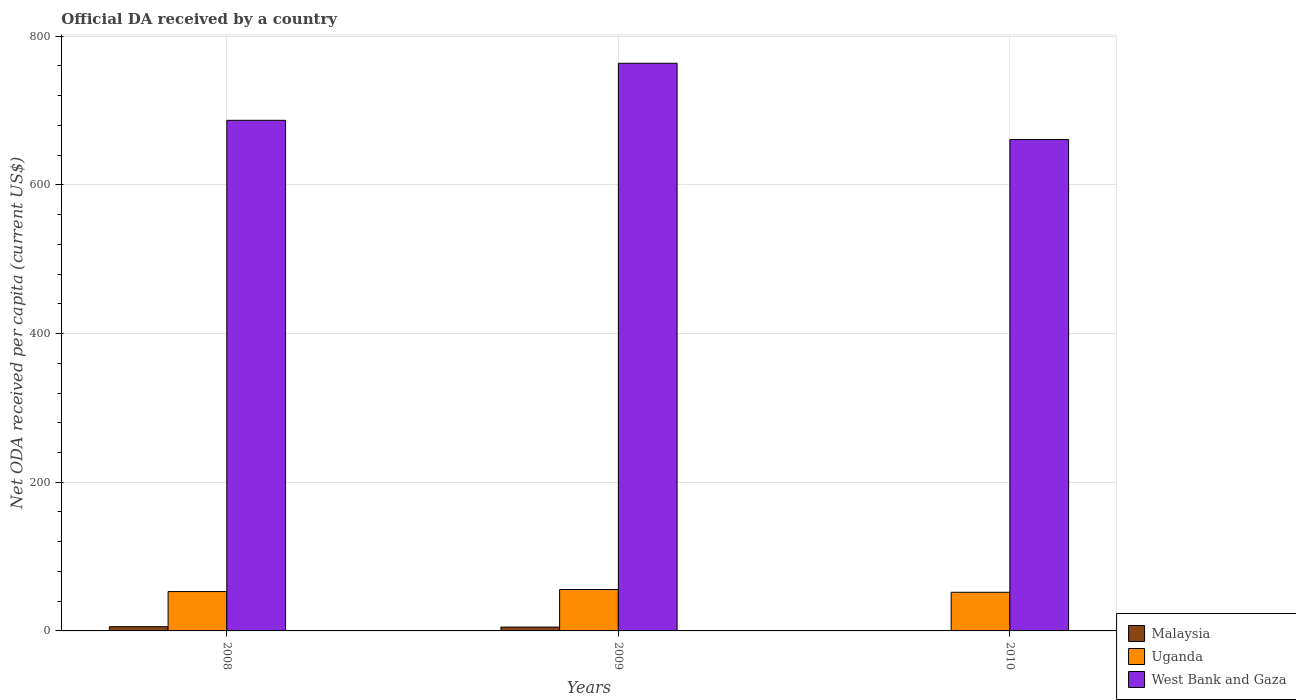Are the number of bars on each tick of the X-axis equal?
Make the answer very short. Yes. What is the label of the 2nd group of bars from the left?
Your answer should be very brief. 2009. What is the ODA received in in Uganda in 2008?
Your answer should be compact. 52.93. Across all years, what is the maximum ODA received in in West Bank and Gaza?
Provide a succinct answer. 763.51. Across all years, what is the minimum ODA received in in Malaysia?
Make the answer very short. 0.07. In which year was the ODA received in in Uganda maximum?
Your answer should be very brief. 2009. In which year was the ODA received in in Malaysia minimum?
Provide a succinct answer. 2010. What is the total ODA received in in Malaysia in the graph?
Your answer should be very brief. 10.92. What is the difference between the ODA received in in West Bank and Gaza in 2008 and that in 2009?
Provide a short and direct response. -76.74. What is the difference between the ODA received in in Malaysia in 2008 and the ODA received in in Uganda in 2010?
Keep it short and to the point. -46.31. What is the average ODA received in in Malaysia per year?
Ensure brevity in your answer.  3.64. In the year 2008, what is the difference between the ODA received in in Uganda and ODA received in in Malaysia?
Ensure brevity in your answer.  47.24. In how many years, is the ODA received in in Malaysia greater than 560 US$?
Keep it short and to the point. 0. What is the ratio of the ODA received in in West Bank and Gaza in 2008 to that in 2009?
Give a very brief answer. 0.9. Is the difference between the ODA received in in Uganda in 2009 and 2010 greater than the difference between the ODA received in in Malaysia in 2009 and 2010?
Provide a succinct answer. No. What is the difference between the highest and the second highest ODA received in in Uganda?
Your answer should be compact. 2.73. What is the difference between the highest and the lowest ODA received in in West Bank and Gaza?
Offer a terse response. 102.62. Is the sum of the ODA received in in Malaysia in 2008 and 2009 greater than the maximum ODA received in in Uganda across all years?
Your answer should be compact. No. What does the 1st bar from the left in 2009 represents?
Provide a succinct answer. Malaysia. What does the 2nd bar from the right in 2008 represents?
Your answer should be very brief. Uganda. Are all the bars in the graph horizontal?
Your response must be concise. No. How many years are there in the graph?
Make the answer very short. 3. What is the difference between two consecutive major ticks on the Y-axis?
Your response must be concise. 200. Are the values on the major ticks of Y-axis written in scientific E-notation?
Provide a succinct answer. No. Does the graph contain any zero values?
Make the answer very short. No. What is the title of the graph?
Give a very brief answer. Official DA received by a country. What is the label or title of the X-axis?
Keep it short and to the point. Years. What is the label or title of the Y-axis?
Offer a very short reply. Net ODA received per capita (current US$). What is the Net ODA received per capita (current US$) in Malaysia in 2008?
Ensure brevity in your answer.  5.68. What is the Net ODA received per capita (current US$) of Uganda in 2008?
Offer a terse response. 52.93. What is the Net ODA received per capita (current US$) in West Bank and Gaza in 2008?
Make the answer very short. 686.77. What is the Net ODA received per capita (current US$) of Malaysia in 2009?
Keep it short and to the point. 5.17. What is the Net ODA received per capita (current US$) in Uganda in 2009?
Provide a succinct answer. 55.66. What is the Net ODA received per capita (current US$) in West Bank and Gaza in 2009?
Your answer should be compact. 763.51. What is the Net ODA received per capita (current US$) in Malaysia in 2010?
Offer a terse response. 0.07. What is the Net ODA received per capita (current US$) of Uganda in 2010?
Ensure brevity in your answer.  51.99. What is the Net ODA received per capita (current US$) in West Bank and Gaza in 2010?
Make the answer very short. 660.88. Across all years, what is the maximum Net ODA received per capita (current US$) of Malaysia?
Your answer should be compact. 5.68. Across all years, what is the maximum Net ODA received per capita (current US$) in Uganda?
Your response must be concise. 55.66. Across all years, what is the maximum Net ODA received per capita (current US$) in West Bank and Gaza?
Provide a succinct answer. 763.51. Across all years, what is the minimum Net ODA received per capita (current US$) of Malaysia?
Your answer should be compact. 0.07. Across all years, what is the minimum Net ODA received per capita (current US$) in Uganda?
Your answer should be compact. 51.99. Across all years, what is the minimum Net ODA received per capita (current US$) in West Bank and Gaza?
Provide a short and direct response. 660.88. What is the total Net ODA received per capita (current US$) of Malaysia in the graph?
Provide a short and direct response. 10.92. What is the total Net ODA received per capita (current US$) in Uganda in the graph?
Your response must be concise. 160.57. What is the total Net ODA received per capita (current US$) in West Bank and Gaza in the graph?
Your response must be concise. 2111.16. What is the difference between the Net ODA received per capita (current US$) in Malaysia in 2008 and that in 2009?
Offer a terse response. 0.51. What is the difference between the Net ODA received per capita (current US$) of Uganda in 2008 and that in 2009?
Give a very brief answer. -2.73. What is the difference between the Net ODA received per capita (current US$) in West Bank and Gaza in 2008 and that in 2009?
Offer a very short reply. -76.74. What is the difference between the Net ODA received per capita (current US$) in Malaysia in 2008 and that in 2010?
Give a very brief answer. 5.61. What is the difference between the Net ODA received per capita (current US$) of Uganda in 2008 and that in 2010?
Offer a terse response. 0.94. What is the difference between the Net ODA received per capita (current US$) in West Bank and Gaza in 2008 and that in 2010?
Provide a succinct answer. 25.88. What is the difference between the Net ODA received per capita (current US$) in Malaysia in 2009 and that in 2010?
Offer a terse response. 5.09. What is the difference between the Net ODA received per capita (current US$) in Uganda in 2009 and that in 2010?
Provide a succinct answer. 3.66. What is the difference between the Net ODA received per capita (current US$) of West Bank and Gaza in 2009 and that in 2010?
Ensure brevity in your answer.  102.62. What is the difference between the Net ODA received per capita (current US$) of Malaysia in 2008 and the Net ODA received per capita (current US$) of Uganda in 2009?
Give a very brief answer. -49.97. What is the difference between the Net ODA received per capita (current US$) in Malaysia in 2008 and the Net ODA received per capita (current US$) in West Bank and Gaza in 2009?
Your response must be concise. -757.83. What is the difference between the Net ODA received per capita (current US$) of Uganda in 2008 and the Net ODA received per capita (current US$) of West Bank and Gaza in 2009?
Offer a terse response. -710.58. What is the difference between the Net ODA received per capita (current US$) of Malaysia in 2008 and the Net ODA received per capita (current US$) of Uganda in 2010?
Offer a very short reply. -46.31. What is the difference between the Net ODA received per capita (current US$) of Malaysia in 2008 and the Net ODA received per capita (current US$) of West Bank and Gaza in 2010?
Your answer should be very brief. -655.2. What is the difference between the Net ODA received per capita (current US$) in Uganda in 2008 and the Net ODA received per capita (current US$) in West Bank and Gaza in 2010?
Your answer should be very brief. -607.96. What is the difference between the Net ODA received per capita (current US$) of Malaysia in 2009 and the Net ODA received per capita (current US$) of Uganda in 2010?
Make the answer very short. -46.82. What is the difference between the Net ODA received per capita (current US$) of Malaysia in 2009 and the Net ODA received per capita (current US$) of West Bank and Gaza in 2010?
Provide a succinct answer. -655.72. What is the difference between the Net ODA received per capita (current US$) in Uganda in 2009 and the Net ODA received per capita (current US$) in West Bank and Gaza in 2010?
Offer a very short reply. -605.23. What is the average Net ODA received per capita (current US$) in Malaysia per year?
Offer a very short reply. 3.64. What is the average Net ODA received per capita (current US$) in Uganda per year?
Offer a very short reply. 53.52. What is the average Net ODA received per capita (current US$) in West Bank and Gaza per year?
Your answer should be very brief. 703.72. In the year 2008, what is the difference between the Net ODA received per capita (current US$) of Malaysia and Net ODA received per capita (current US$) of Uganda?
Ensure brevity in your answer.  -47.24. In the year 2008, what is the difference between the Net ODA received per capita (current US$) in Malaysia and Net ODA received per capita (current US$) in West Bank and Gaza?
Provide a succinct answer. -681.08. In the year 2008, what is the difference between the Net ODA received per capita (current US$) of Uganda and Net ODA received per capita (current US$) of West Bank and Gaza?
Your response must be concise. -633.84. In the year 2009, what is the difference between the Net ODA received per capita (current US$) of Malaysia and Net ODA received per capita (current US$) of Uganda?
Your answer should be compact. -50.49. In the year 2009, what is the difference between the Net ODA received per capita (current US$) in Malaysia and Net ODA received per capita (current US$) in West Bank and Gaza?
Ensure brevity in your answer.  -758.34. In the year 2009, what is the difference between the Net ODA received per capita (current US$) of Uganda and Net ODA received per capita (current US$) of West Bank and Gaza?
Ensure brevity in your answer.  -707.85. In the year 2010, what is the difference between the Net ODA received per capita (current US$) in Malaysia and Net ODA received per capita (current US$) in Uganda?
Provide a succinct answer. -51.92. In the year 2010, what is the difference between the Net ODA received per capita (current US$) in Malaysia and Net ODA received per capita (current US$) in West Bank and Gaza?
Offer a very short reply. -660.81. In the year 2010, what is the difference between the Net ODA received per capita (current US$) of Uganda and Net ODA received per capita (current US$) of West Bank and Gaza?
Ensure brevity in your answer.  -608.89. What is the ratio of the Net ODA received per capita (current US$) in Malaysia in 2008 to that in 2009?
Give a very brief answer. 1.1. What is the ratio of the Net ODA received per capita (current US$) in Uganda in 2008 to that in 2009?
Make the answer very short. 0.95. What is the ratio of the Net ODA received per capita (current US$) of West Bank and Gaza in 2008 to that in 2009?
Provide a succinct answer. 0.9. What is the ratio of the Net ODA received per capita (current US$) of Malaysia in 2008 to that in 2010?
Your answer should be compact. 77.55. What is the ratio of the Net ODA received per capita (current US$) of West Bank and Gaza in 2008 to that in 2010?
Provide a short and direct response. 1.04. What is the ratio of the Net ODA received per capita (current US$) in Malaysia in 2009 to that in 2010?
Offer a terse response. 70.55. What is the ratio of the Net ODA received per capita (current US$) of Uganda in 2009 to that in 2010?
Your answer should be compact. 1.07. What is the ratio of the Net ODA received per capita (current US$) in West Bank and Gaza in 2009 to that in 2010?
Your answer should be compact. 1.16. What is the difference between the highest and the second highest Net ODA received per capita (current US$) in Malaysia?
Offer a very short reply. 0.51. What is the difference between the highest and the second highest Net ODA received per capita (current US$) in Uganda?
Ensure brevity in your answer.  2.73. What is the difference between the highest and the second highest Net ODA received per capita (current US$) in West Bank and Gaza?
Offer a terse response. 76.74. What is the difference between the highest and the lowest Net ODA received per capita (current US$) in Malaysia?
Provide a short and direct response. 5.61. What is the difference between the highest and the lowest Net ODA received per capita (current US$) in Uganda?
Offer a very short reply. 3.66. What is the difference between the highest and the lowest Net ODA received per capita (current US$) in West Bank and Gaza?
Provide a short and direct response. 102.62. 